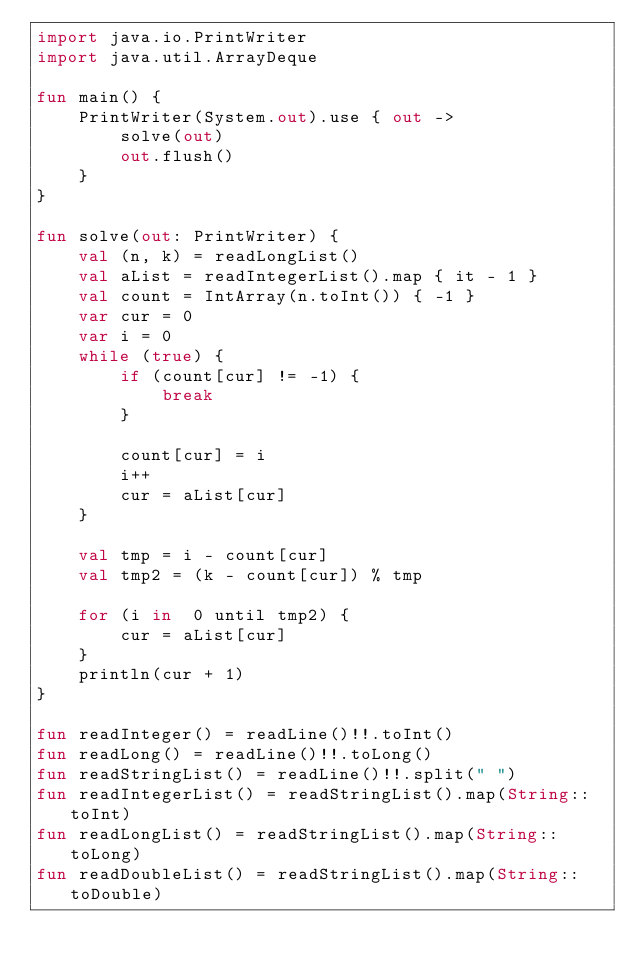Convert code to text. <code><loc_0><loc_0><loc_500><loc_500><_Kotlin_>import java.io.PrintWriter
import java.util.ArrayDeque

fun main() {
    PrintWriter(System.out).use { out ->
        solve(out)
        out.flush()
    }
}

fun solve(out: PrintWriter) {
    val (n, k) = readLongList()
    val aList = readIntegerList().map { it - 1 }
    val count = IntArray(n.toInt()) { -1 }
    var cur = 0
    var i = 0
    while (true) {
        if (count[cur] != -1) {
            break
        }

        count[cur] = i
        i++
        cur = aList[cur]
    }

    val tmp = i - count[cur]
    val tmp2 = (k - count[cur]) % tmp

    for (i in  0 until tmp2) {
        cur = aList[cur]
    }
    println(cur + 1)
}

fun readInteger() = readLine()!!.toInt()
fun readLong() = readLine()!!.toLong()
fun readStringList() = readLine()!!.split(" ")
fun readIntegerList() = readStringList().map(String::toInt)
fun readLongList() = readStringList().map(String::toLong)
fun readDoubleList() = readStringList().map(String::toDouble)
</code> 